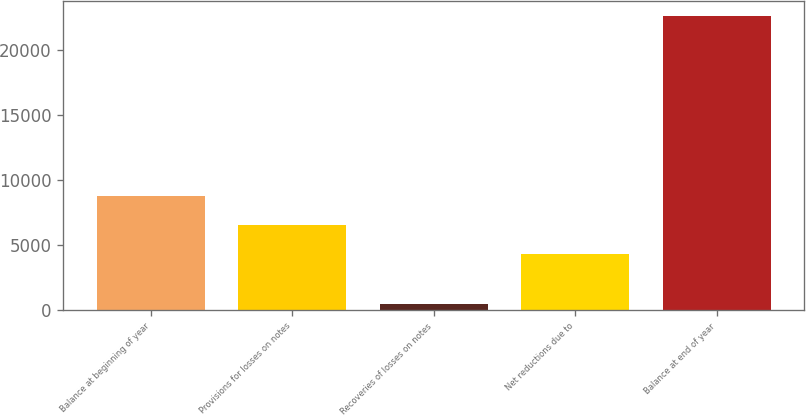Convert chart to OTSL. <chart><loc_0><loc_0><loc_500><loc_500><bar_chart><fcel>Balance at beginning of year<fcel>Provisions for losses on notes<fcel>Recoveries of losses on notes<fcel>Net reductions due to<fcel>Balance at end of year<nl><fcel>8764.4<fcel>6546.7<fcel>429<fcel>4329<fcel>22606<nl></chart> 